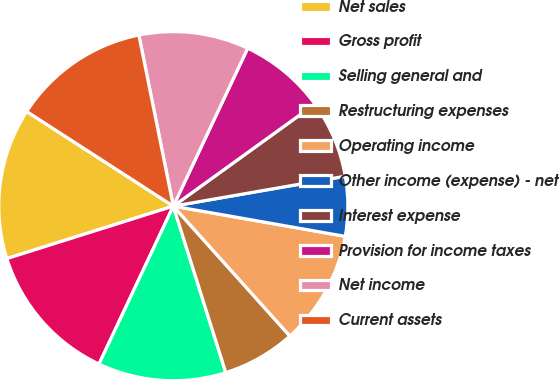Convert chart to OTSL. <chart><loc_0><loc_0><loc_500><loc_500><pie_chart><fcel>Net sales<fcel>Gross profit<fcel>Selling general and<fcel>Restructuring expenses<fcel>Operating income<fcel>Other income (expense) - net<fcel>Interest expense<fcel>Provision for income taxes<fcel>Net income<fcel>Current assets<nl><fcel>13.98%<fcel>13.14%<fcel>11.86%<fcel>6.78%<fcel>10.59%<fcel>5.51%<fcel>7.2%<fcel>8.05%<fcel>10.17%<fcel>12.71%<nl></chart> 